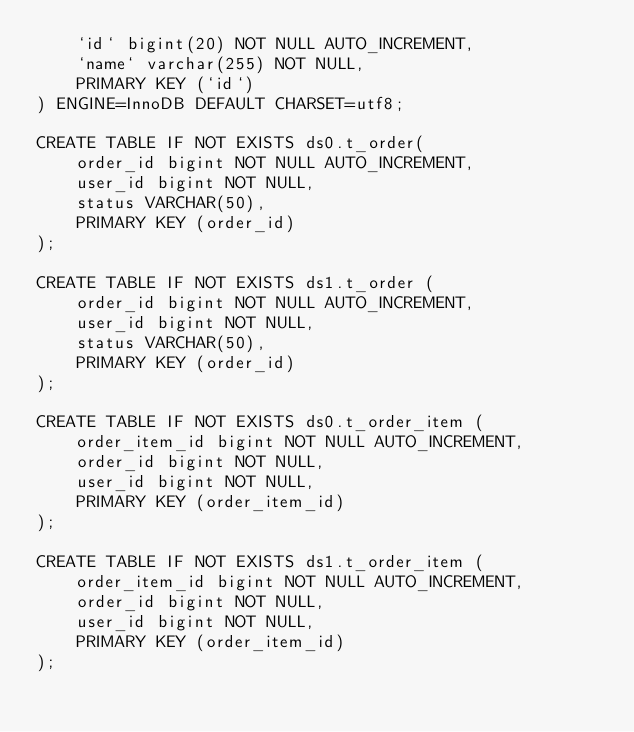Convert code to text. <code><loc_0><loc_0><loc_500><loc_500><_SQL_>    `id` bigint(20) NOT NULL AUTO_INCREMENT,
    `name` varchar(255) NOT NULL,
    PRIMARY KEY (`id`)
) ENGINE=InnoDB DEFAULT CHARSET=utf8;

CREATE TABLE IF NOT EXISTS ds0.t_order(
    order_id bigint NOT NULL AUTO_INCREMENT,
    user_id bigint NOT NULL,
    status VARCHAR(50),
    PRIMARY KEY (order_id)
);

CREATE TABLE IF NOT EXISTS ds1.t_order (
    order_id bigint NOT NULL AUTO_INCREMENT,
    user_id bigint NOT NULL,
    status VARCHAR(50),
    PRIMARY KEY (order_id)
);

CREATE TABLE IF NOT EXISTS ds0.t_order_item (
    order_item_id bigint NOT NULL AUTO_INCREMENT,
    order_id bigint NOT NULL,
    user_id bigint NOT NULL,
    PRIMARY KEY (order_item_id)
);

CREATE TABLE IF NOT EXISTS ds1.t_order_item (
    order_item_id bigint NOT NULL AUTO_INCREMENT,
    order_id bigint NOT NULL,
    user_id bigint NOT NULL,
    PRIMARY KEY (order_item_id)
);
</code> 